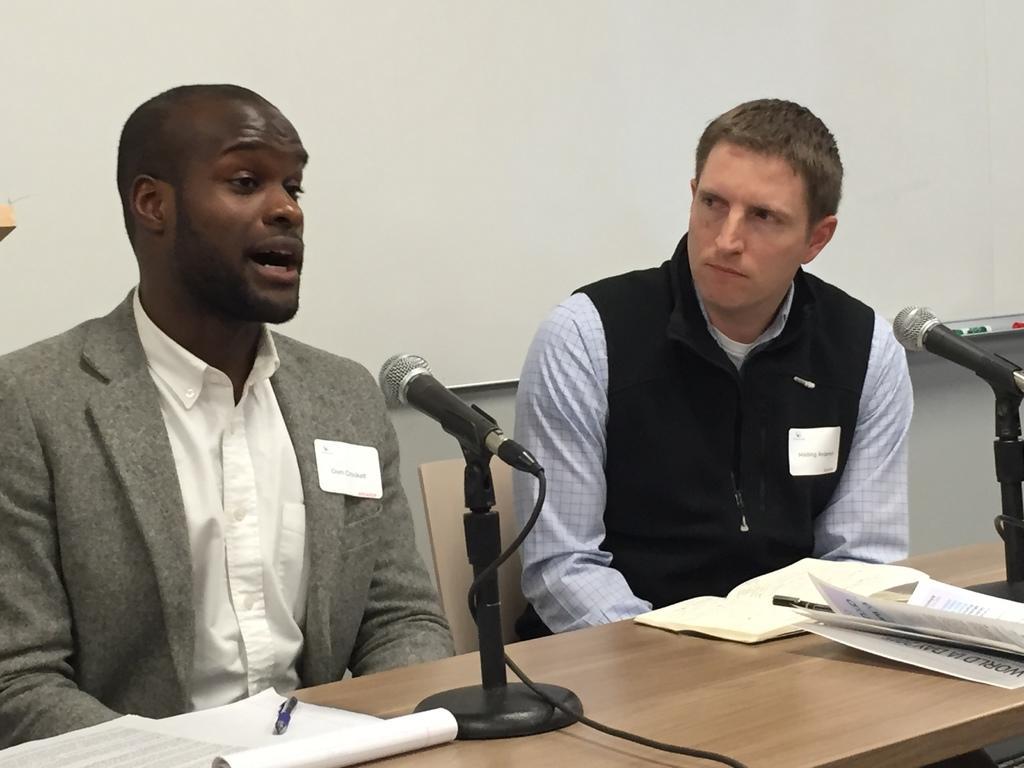How would you summarize this image in a sentence or two? In this image, there are a few people. We can see a table with some books, posters and microphones. We can see the wall with some objects. We can also see an object on the left. 